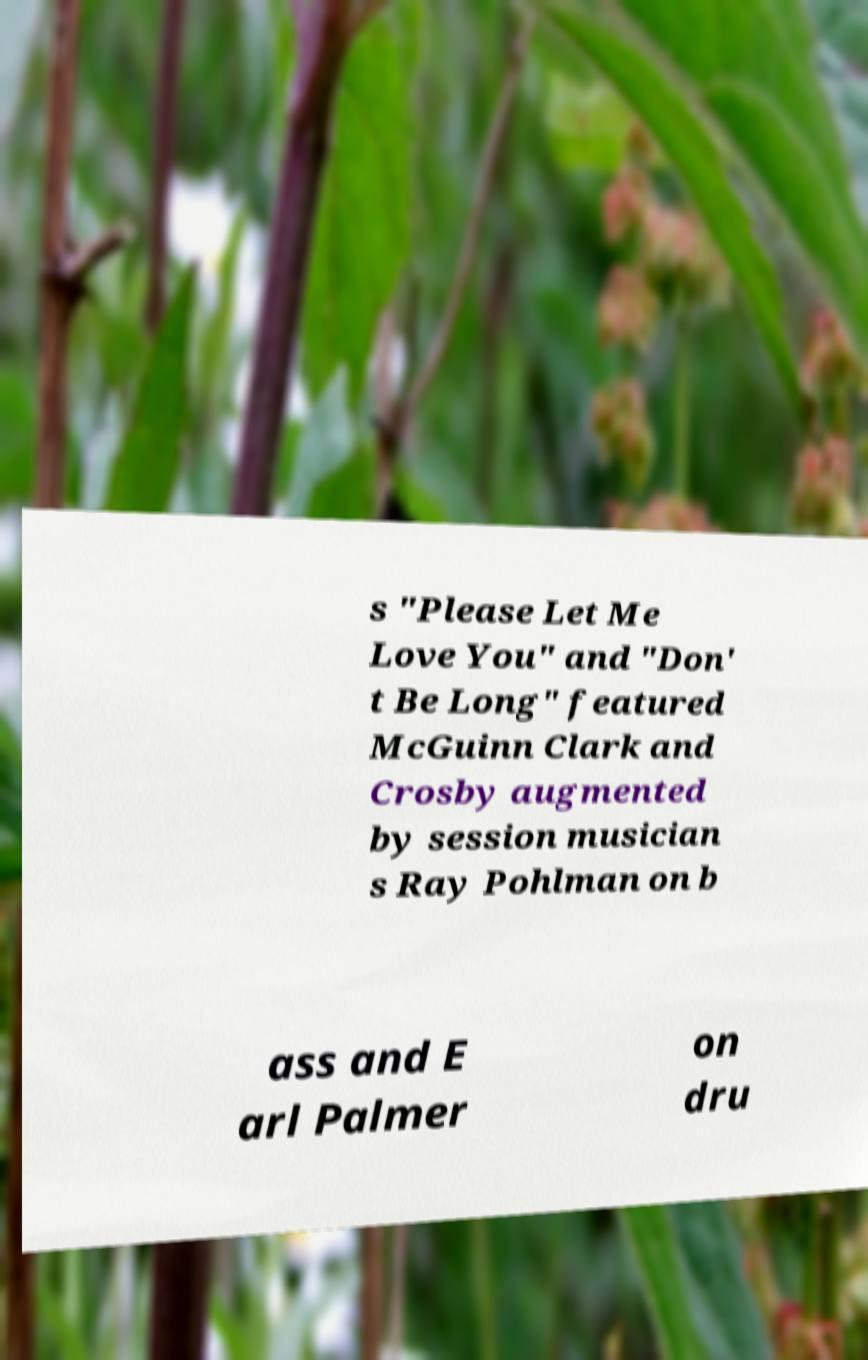Could you assist in decoding the text presented in this image and type it out clearly? s "Please Let Me Love You" and "Don' t Be Long" featured McGuinn Clark and Crosby augmented by session musician s Ray Pohlman on b ass and E arl Palmer on dru 